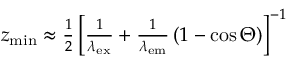Convert formula to latex. <formula><loc_0><loc_0><loc_500><loc_500>\begin{array} { r } { z _ { \min } \approx \frac { 1 } { 2 } \left [ \frac { 1 } { \lambda _ { e x } } + \frac { 1 } { \lambda _ { e m } } \left ( 1 - \cos \Theta \right ) \right ] ^ { - 1 } } \end{array}</formula> 